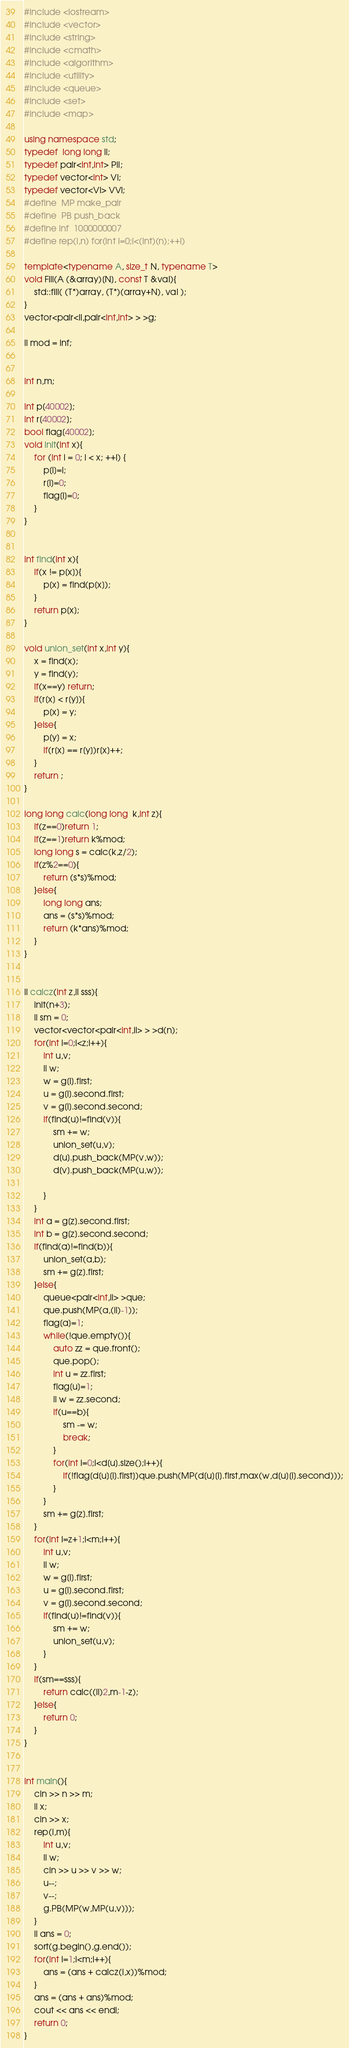<code> <loc_0><loc_0><loc_500><loc_500><_C++_>#include <iostream>
#include <vector>
#include <string>
#include <cmath>
#include <algorithm>
#include <utility>
#include <queue>
#include <set>
#include <map>

using namespace std;
typedef  long long ll;
typedef pair<int,int> PII;
typedef vector<int> VI;
typedef vector<VI> VVI;
#define  MP make_pair
#define  PB push_back
#define inf  1000000007
#define rep(i,n) for(int i=0;i<(int)(n);++i)

template<typename A, size_t N, typename T>
void Fill(A (&array)[N], const T &val){
    std::fill( (T*)array, (T*)(array+N), val );
}
vector<pair<ll,pair<int,int> > >g; 

ll mod = inf;


int n,m;

int p[40002];
int r[40002];
bool flag[40002];
void init(int x){
    for (int i = 0; i < x; ++i) {
        p[i]=i;
        r[i]=0;
      	flag[i]=0;
    }
}


int find(int x){
	if(x != p[x]){
		p[x] = find(p[x]);
    }
   	return p[x];
}
     
void union_set(int x,int y){
	x = find(x);
	y = find(y);
	if(x==y) return;
	if(r[x] < r[y]){
		p[x] = y;	
	}else{
		p[y] = x;
		if(r[x] == r[y])r[x]++;
	}
	return ;
}

long long calc(long long  k,int z){
	if(z==0)return 1;
	if(z==1)return k%mod;
	long long s = calc(k,z/2);
	if(z%2==0){
		return (s*s)%mod;
	}else{
		long long ans;
		ans = (s*s)%mod;
		return (k*ans)%mod;
	}
}


ll calcz(int z,ll sss){
    init(n+3);
    ll sm = 0;
    vector<vector<pair<int,ll> > >d(n);
    for(int i=0;i<z;i++){
        int u,v;
        ll w;
        w = g[i].first;
        u = g[i].second.first;
        v = g[i].second.second;
        if(find(u)!=find(v)){
            sm += w;
            union_set(u,v);
            d[u].push_back(MP(v,w));
            d[v].push_back(MP(u,w));
           
        }
    }
    int a = g[z].second.first;
    int b = g[z].second.second;
    if(find(a)!=find(b)){
        union_set(a,b);
        sm += g[z].first;
    }else{
        queue<pair<int,ll> >que;
        que.push(MP(a,(ll)-1));
      	flag[a]=1;
        while(!que.empty()){
            auto zz = que.front();
            que.pop();
            int u = zz.first;
          	flag[u]=1;
            ll w = zz.second;
            if(u==b){
                sm -= w;
                break;
            }
            for(int i=0;i<d[u].size();i++){
                if(!flag[d[u][i].first])que.push(MP(d[u][i].first,max(w,d[u][i].second)));
            }
        }
        sm += g[z].first;
    }
    for(int i=z+1;i<m;i++){
        int u,v;
        ll w;
        w = g[i].first;
        u = g[i].second.first;
        v = g[i].second.second;
        if(find(u)!=find(v)){
            sm += w;
            union_set(u,v);
        }
    }
    if(sm==sss){
        return calc((ll)2,m-1-z);
    }else{
        return 0;
    }
}


int main(){
    cin >> n >> m;
    ll x;
    cin >> x;
    rep(i,m){
        int u,v;
        ll w;
        cin >> u >> v >> w;
        u--;
        v--;
        g.PB(MP(w,MP(u,v)));
    }
    ll ans = 0;
    sort(g.begin(),g.end());
    for(int i=1;i<m;i++){
        ans = (ans + calcz(i,x))%mod;
    }
    ans = (ans + ans)%mod;
    cout << ans << endl;
    return 0;
}
</code> 